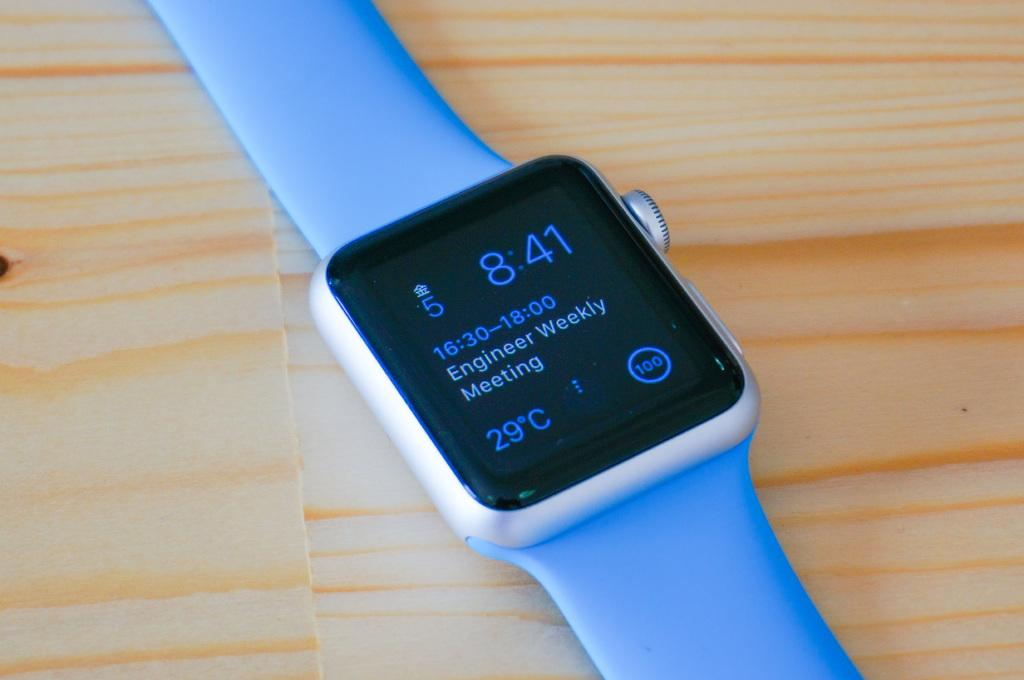<image>
Write a terse but informative summary of the picture. At 16:30 the watch owner is going to an engineer meeting. 